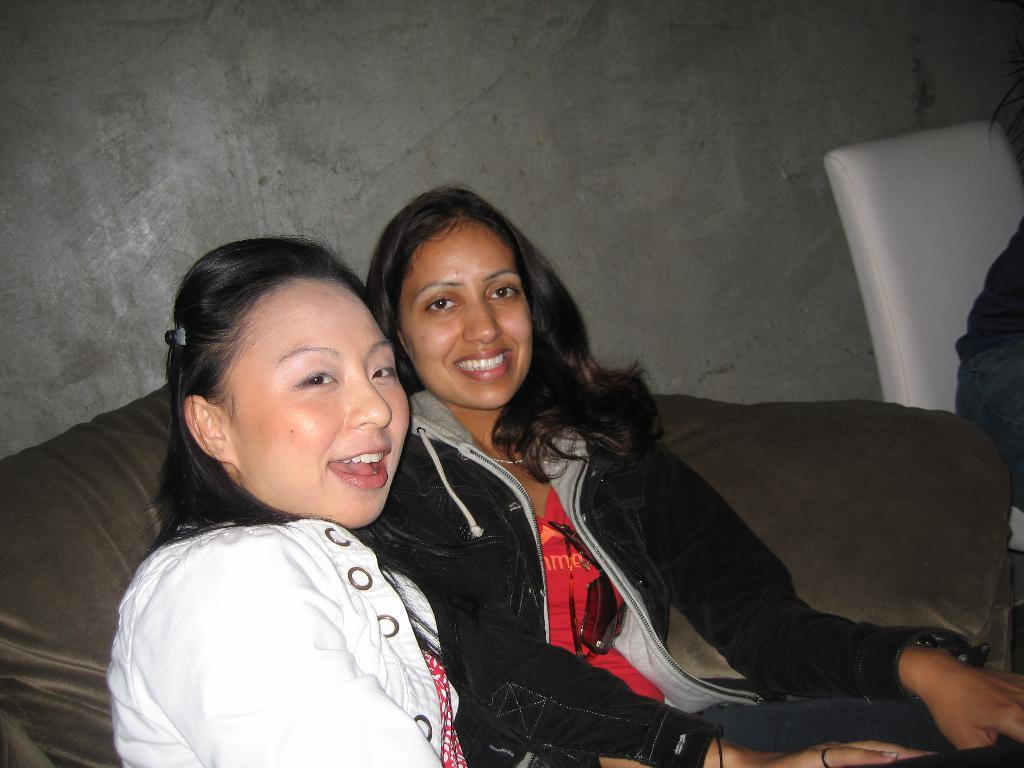How many women are in the image? There are two women in the image. What are the women doing in the image? The women are sitting on a sofa and smiling. Can you describe the seating arrangement of the other person in the image? The other person is sitting in a chair. What type of produce can be seen on the table in the image? There is no table or produce present in the image. Can you tell me how many cattle are visible in the image? There are no cattle visible in the image. 